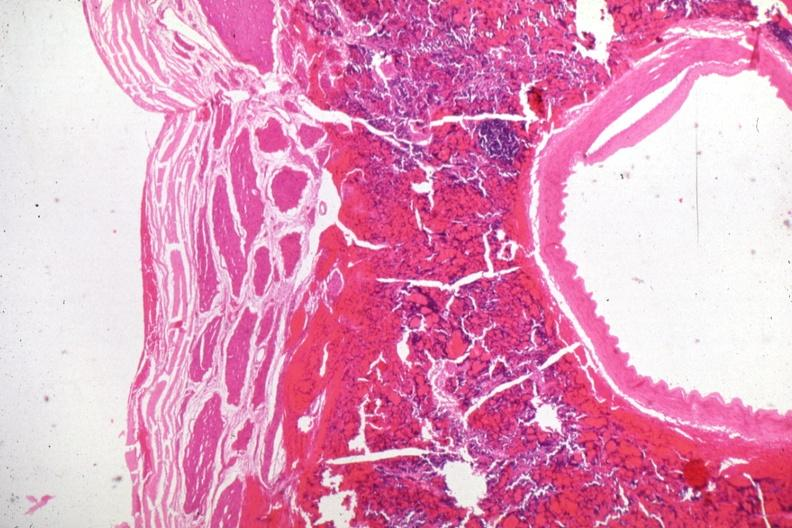s malignant adenoma present?
Answer the question using a single word or phrase. Yes 